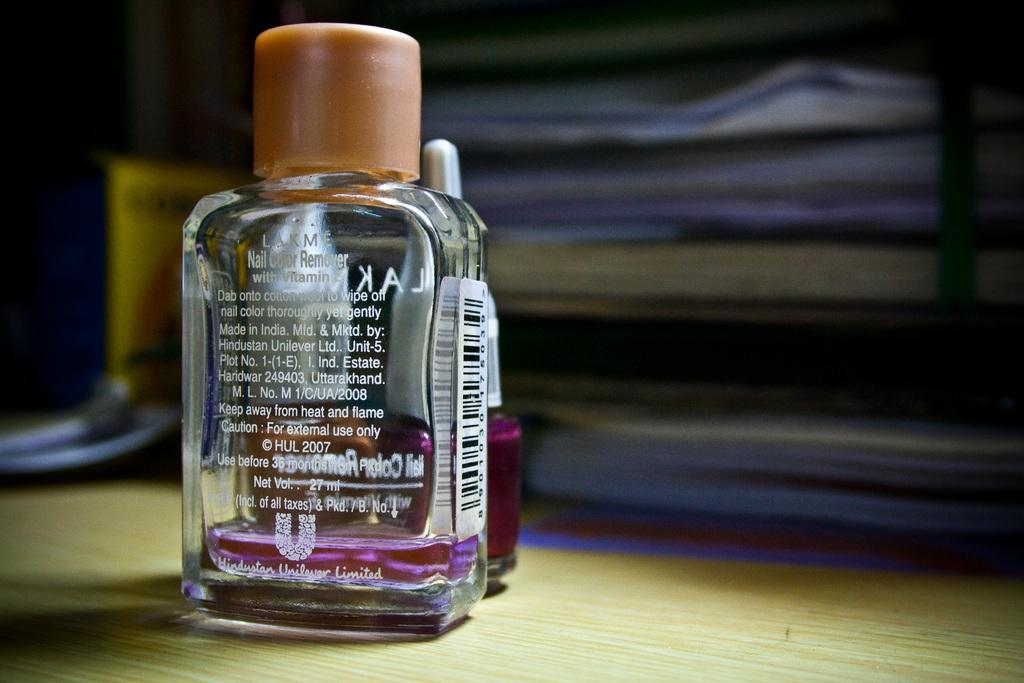Provide a one-sentence caption for the provided image. Clear bottle of Nail Color Remover on top of a desk. 